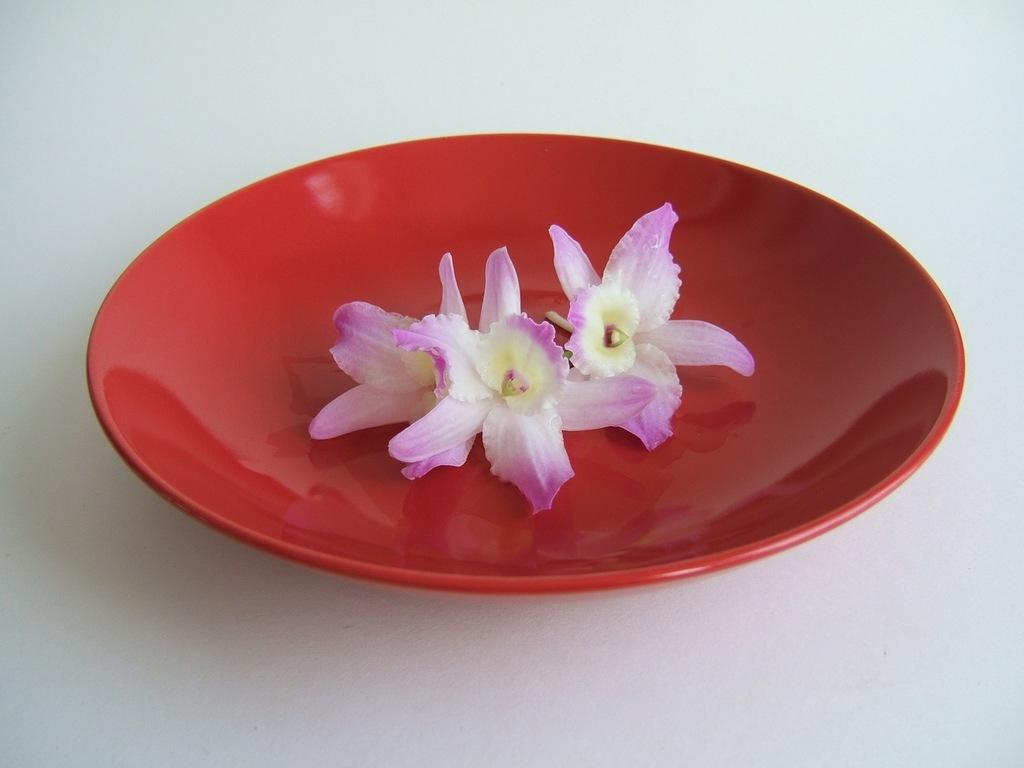What type of living organisms are present in the image? There are flowers in the image. How are the flowers arranged or displayed in the image? The flowers are on a plate. What is the color of the plate that holds the flowers? The plate is red in color. How many pigs are visible in the image? There are no pigs present in the image. What type of comb is being used to groom the flowers in the image? There is no comb present in the image, and flowers do not require grooming. 